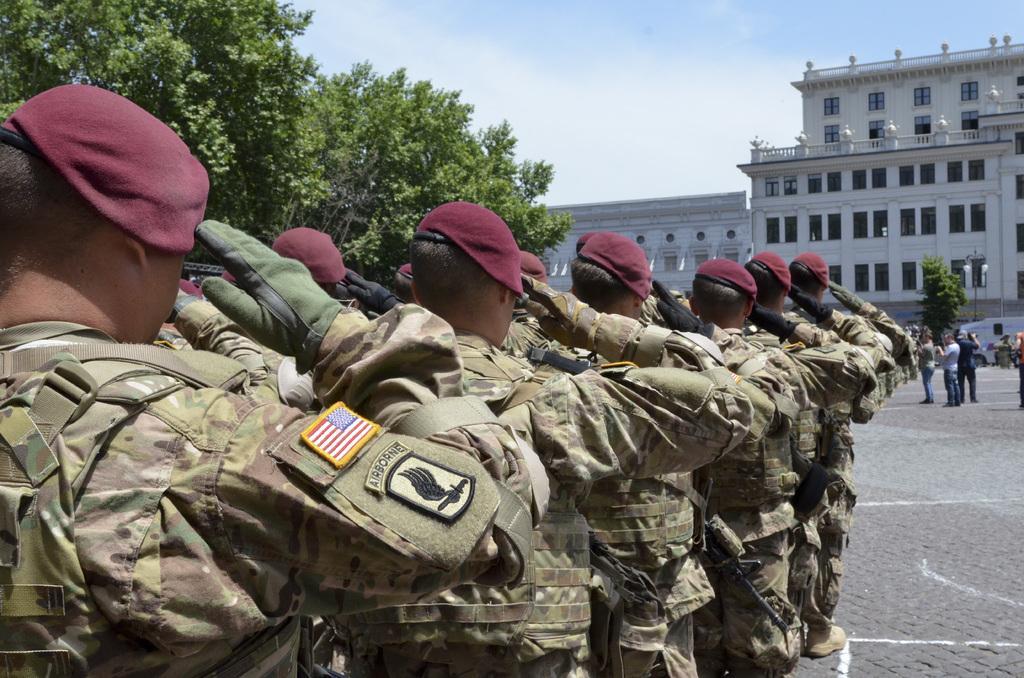Can you describe this image briefly? In this image we can see these people wearing uniforms, caps, gloves and shoes are standing on the road and saluting. Here we can see a few more people standing on the road, we can see trees, a vehicle, light poles, building and the sky with clouds in the background. 